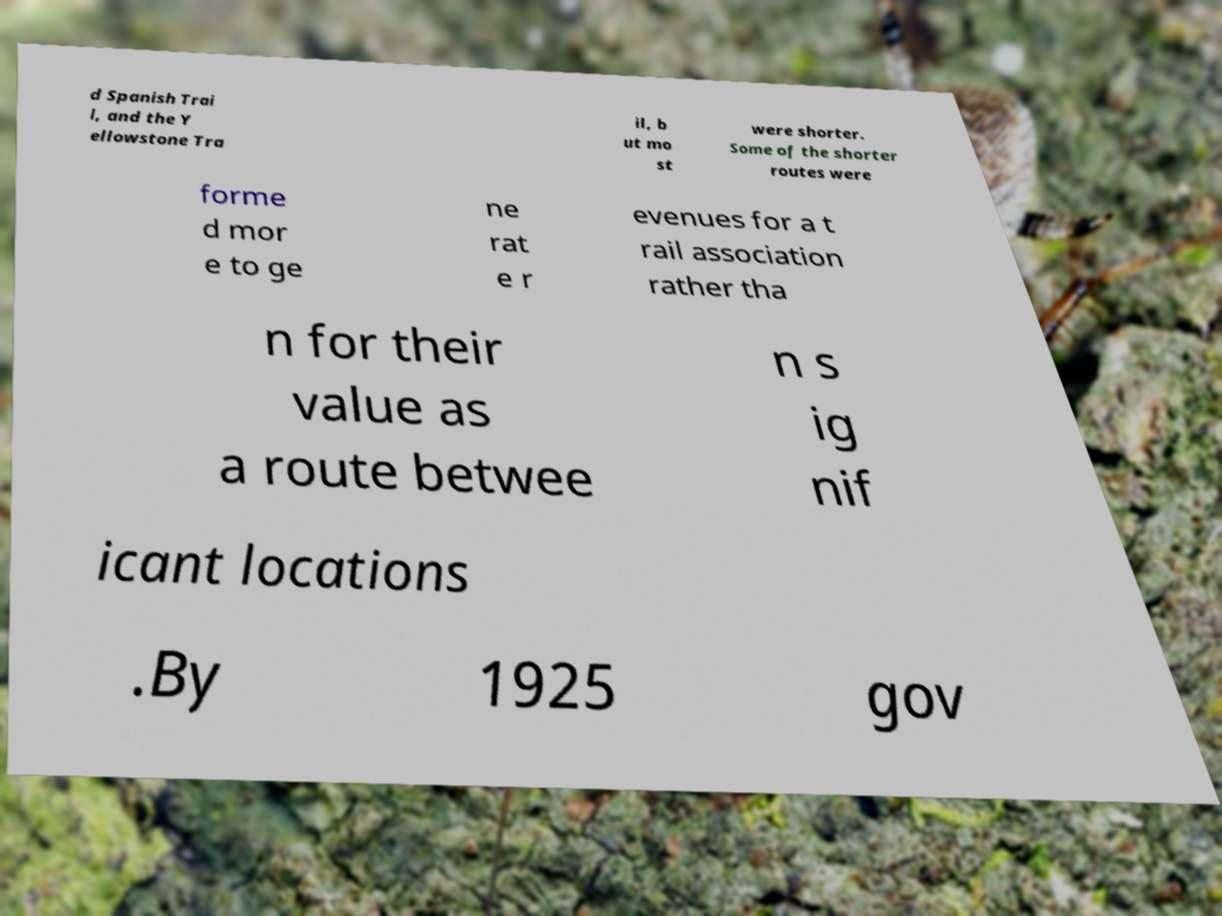Could you extract and type out the text from this image? d Spanish Trai l, and the Y ellowstone Tra il, b ut mo st were shorter. Some of the shorter routes were forme d mor e to ge ne rat e r evenues for a t rail association rather tha n for their value as a route betwee n s ig nif icant locations .By 1925 gov 